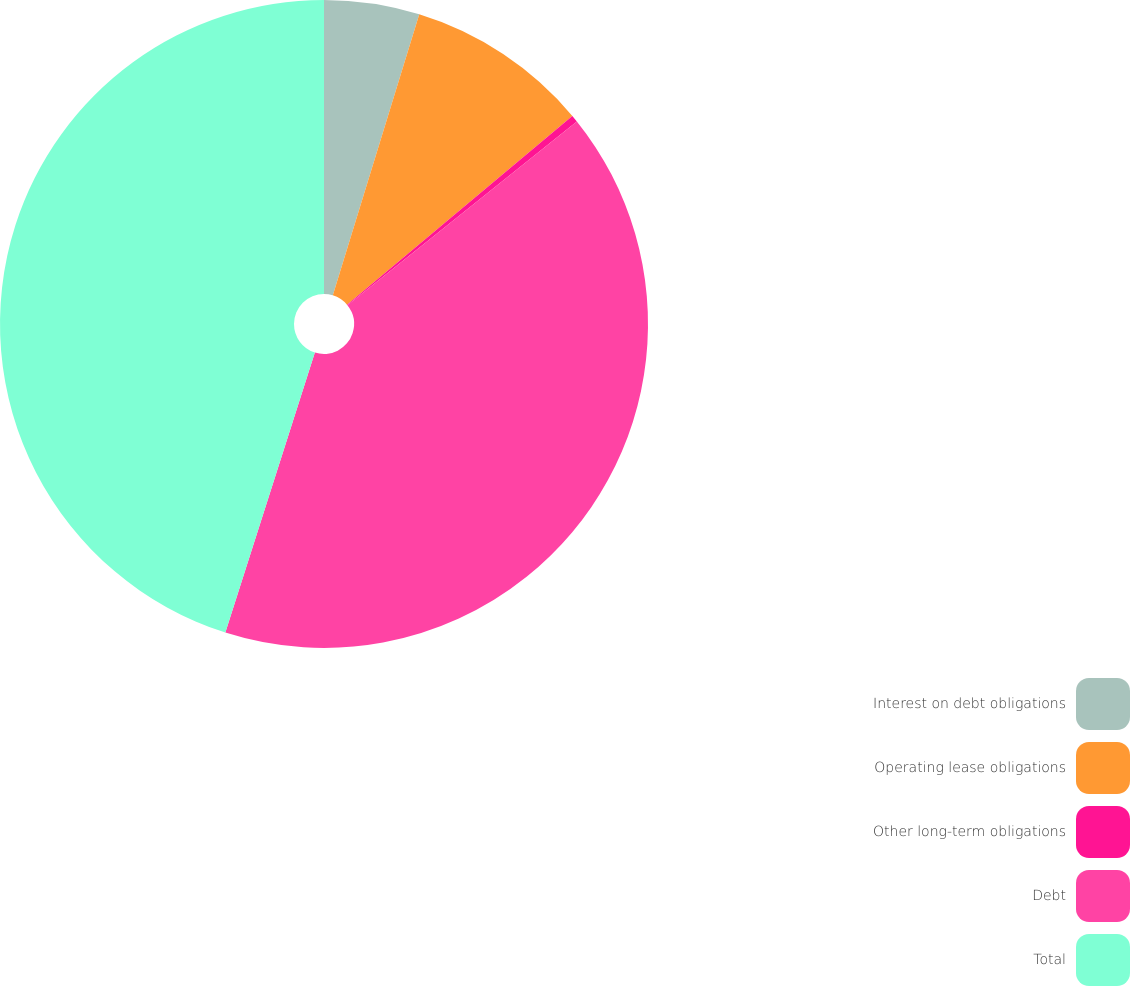<chart> <loc_0><loc_0><loc_500><loc_500><pie_chart><fcel>Interest on debt obligations<fcel>Operating lease obligations<fcel>Other long-term obligations<fcel>Debt<fcel>Total<nl><fcel>4.75%<fcel>9.15%<fcel>0.35%<fcel>40.68%<fcel>45.08%<nl></chart> 